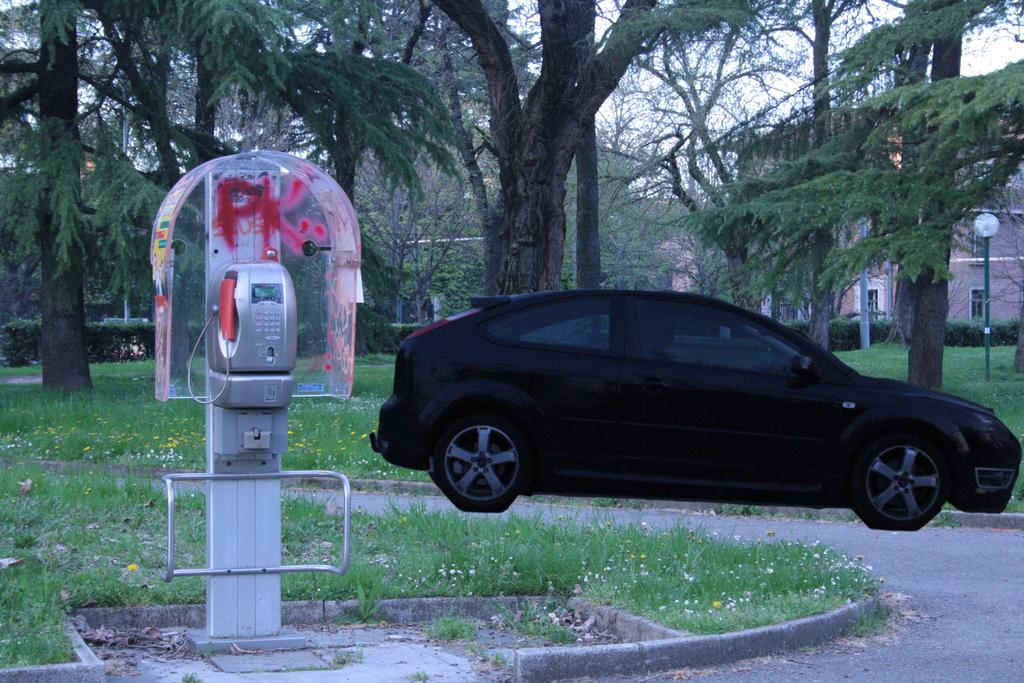What type of vehicle is in the image? There is a black car in the image. What object is located to the left of the car? There is a telephone to the left of the car. What type of vegetation is visible at the bottom of the image? Green grass is visible at the bottom of the image. What can be seen in the background of the image? There are many trees in the background of the image. What type of lamp is on the car's dashboard in the image? There is no lamp visible on the car's dashboard in the image. 